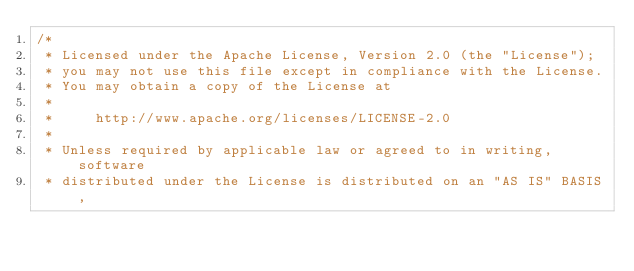<code> <loc_0><loc_0><loc_500><loc_500><_Java_>/*
 * Licensed under the Apache License, Version 2.0 (the "License");
 * you may not use this file except in compliance with the License.
 * You may obtain a copy of the License at
 *
 *     http://www.apache.org/licenses/LICENSE-2.0
 *
 * Unless required by applicable law or agreed to in writing, software
 * distributed under the License is distributed on an "AS IS" BASIS,</code> 